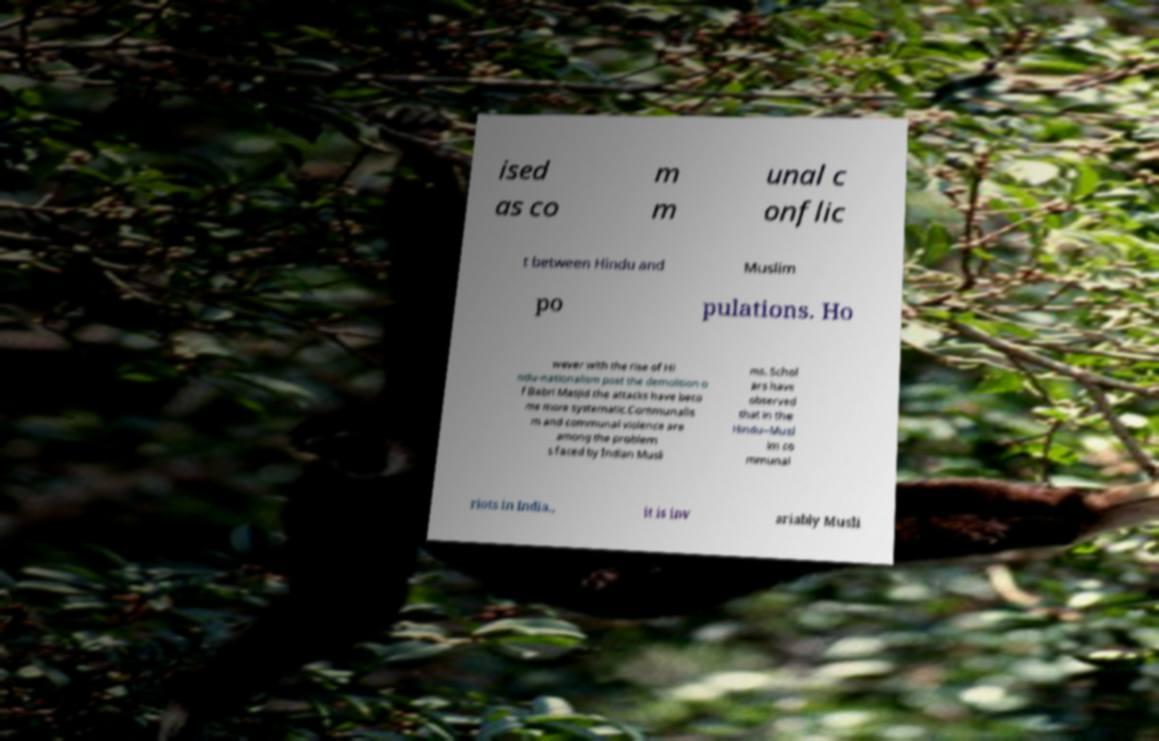For documentation purposes, I need the text within this image transcribed. Could you provide that? ised as co m m unal c onflic t between Hindu and Muslim po pulations. Ho wever with the rise of Hi ndu-nationalism post the demolition o f Babri Masjid the attacks have beco me more systematic.Communalis m and communal violence are among the problem s faced by Indian Musli ms. Schol ars have observed that in the Hindu–Musl im co mmunal riots in India., it is inv ariably Musli 